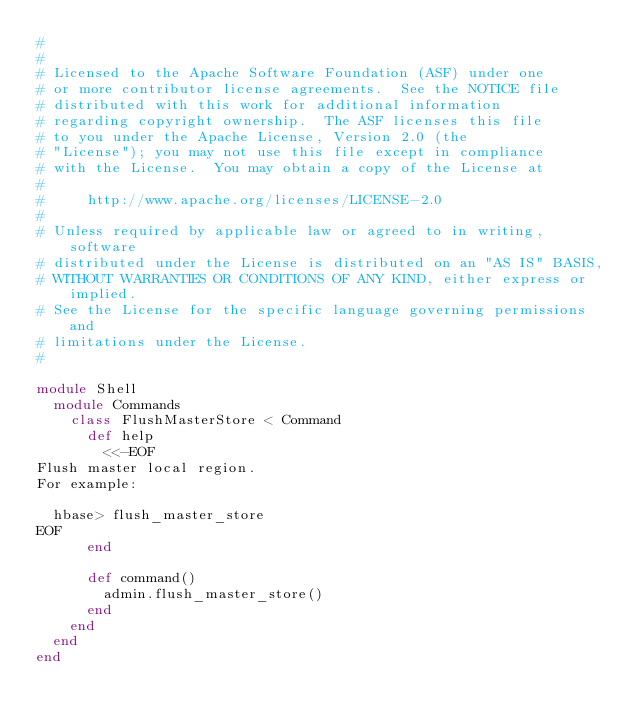<code> <loc_0><loc_0><loc_500><loc_500><_Ruby_>#
#
# Licensed to the Apache Software Foundation (ASF) under one
# or more contributor license agreements.  See the NOTICE file
# distributed with this work for additional information
# regarding copyright ownership.  The ASF licenses this file
# to you under the Apache License, Version 2.0 (the
# "License"); you may not use this file except in compliance
# with the License.  You may obtain a copy of the License at
#
#     http://www.apache.org/licenses/LICENSE-2.0
#
# Unless required by applicable law or agreed to in writing, software
# distributed under the License is distributed on an "AS IS" BASIS,
# WITHOUT WARRANTIES OR CONDITIONS OF ANY KIND, either express or implied.
# See the License for the specific language governing permissions and
# limitations under the License.
#

module Shell
  module Commands
    class FlushMasterStore < Command
      def help
        <<-EOF
Flush master local region.
For example:

  hbase> flush_master_store
EOF
      end

      def command()
        admin.flush_master_store()
      end
    end
  end
end
</code> 